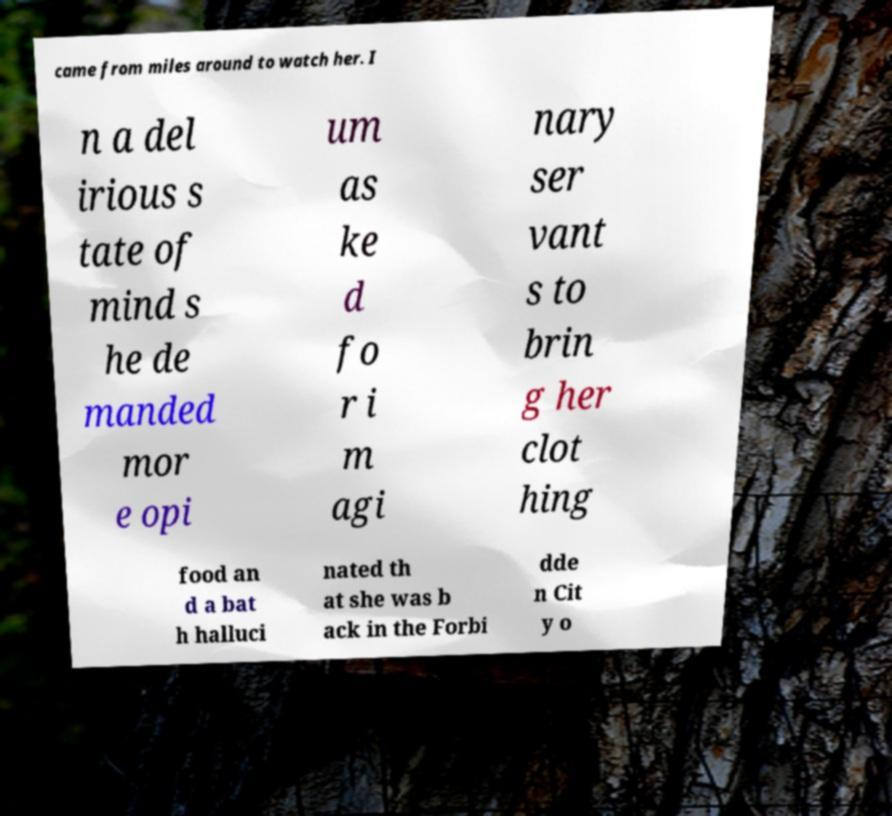Could you assist in decoding the text presented in this image and type it out clearly? came from miles around to watch her. I n a del irious s tate of mind s he de manded mor e opi um as ke d fo r i m agi nary ser vant s to brin g her clot hing food an d a bat h halluci nated th at she was b ack in the Forbi dde n Cit y o 